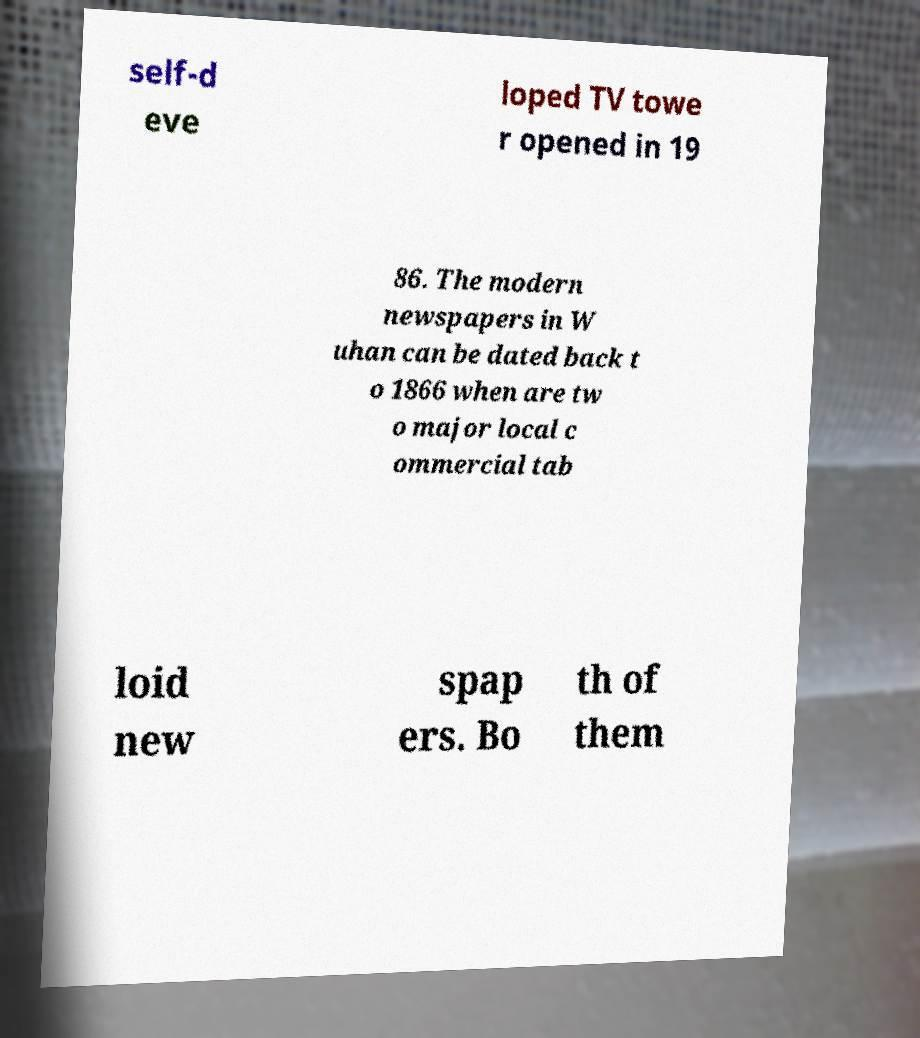There's text embedded in this image that I need extracted. Can you transcribe it verbatim? self-d eve loped TV towe r opened in 19 86. The modern newspapers in W uhan can be dated back t o 1866 when are tw o major local c ommercial tab loid new spap ers. Bo th of them 